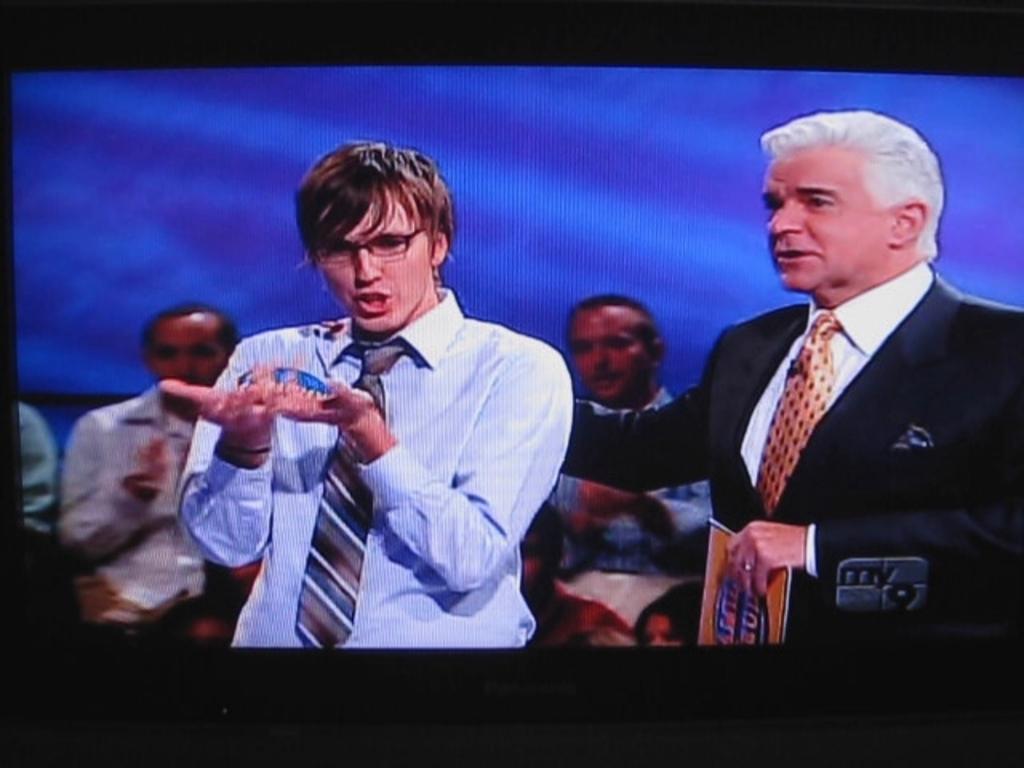What tv program is that?
Offer a very short reply. Family feud. What is the name of the network icon the show is playing on?
Your response must be concise. My 9. 